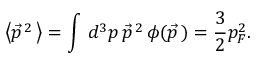Convert formula to latex. <formula><loc_0><loc_0><loc_500><loc_500>\left < \vec { p } ^ { \, 2 } \, \right > = \int \, d ^ { 3 } p \, \vec { p } ^ { \, 2 } \, \phi ( \vec { p } \, ) = { \frac { 3 } { 2 } } p _ { F } ^ { 2 } .</formula> 